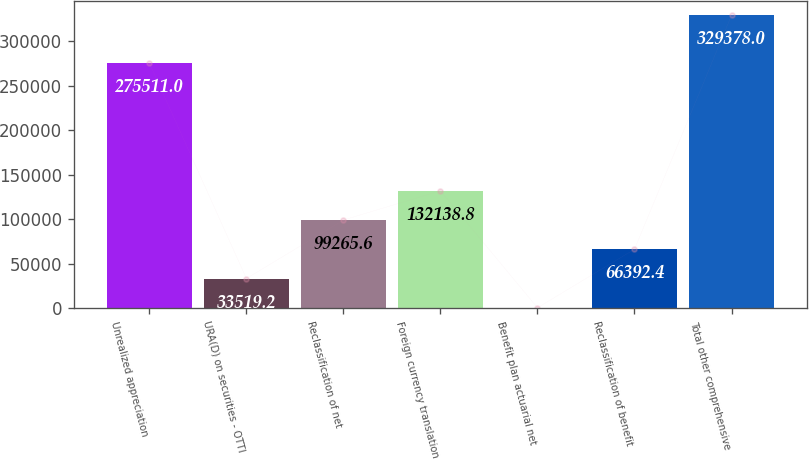<chart> <loc_0><loc_0><loc_500><loc_500><bar_chart><fcel>Unrealized appreciation<fcel>URA(D) on securities - OTTI<fcel>Reclassification of net<fcel>Foreign currency translation<fcel>Benefit plan actuarial net<fcel>Reclassification of benefit<fcel>Total other comprehensive<nl><fcel>275511<fcel>33519.2<fcel>99265.6<fcel>132139<fcel>646<fcel>66392.4<fcel>329378<nl></chart> 